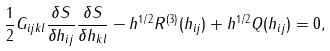Convert formula to latex. <formula><loc_0><loc_0><loc_500><loc_500>\frac { 1 } { 2 } G _ { i j k l } \frac { \delta S } { \delta h _ { i j } } \frac { \delta S } { \delta h _ { k l } } - h ^ { 1 / 2 } R ^ { ( 3 ) } ( h _ { i j } ) + h ^ { 1 / 2 } Q ( h _ { i j } ) = 0 ,</formula> 